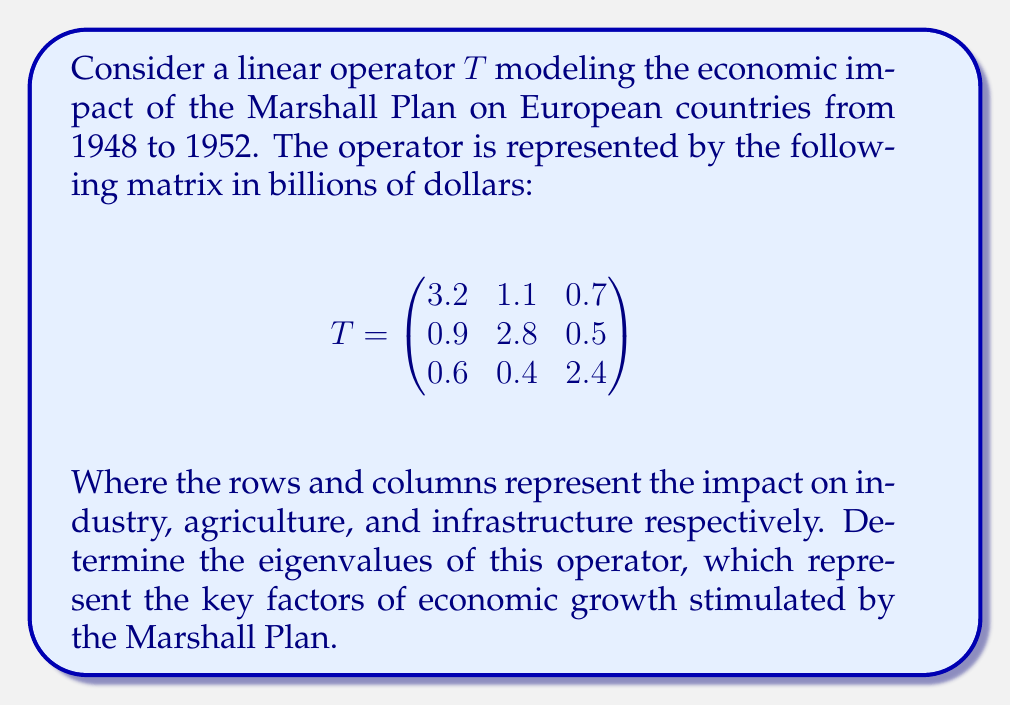Show me your answer to this math problem. To find the eigenvalues of the linear operator T, we need to solve the characteristic equation:

$det(T - \lambda I) = 0$

Where $I$ is the 3x3 identity matrix and $\lambda$ represents the eigenvalues.

Step 1: Set up the characteristic equation:
$$det\begin{pmatrix}
3.2 - \lambda & 1.1 & 0.7 \\
0.9 & 2.8 - \lambda & 0.5 \\
0.6 & 0.4 & 2.4 - \lambda
\end{pmatrix} = 0$$

Step 2: Expand the determinant:
$$(3.2 - \lambda)[(2.8 - \lambda)(2.4 - \lambda) - 0.2] - 1.1[0.9(2.4 - \lambda) - 0.3] + 0.7[0.9(0.4) - 0.6(2.8 - \lambda)] = 0$$

Step 3: Simplify and collect terms:
$$\lambda^3 - 8.4\lambda^2 + 22.12\lambda - 18.256 = 0$$

Step 4: Solve the cubic equation. This can be done using the cubic formula or numerical methods. The roots of this equation are the eigenvalues.

Using a numerical solver, we find the eigenvalues to be approximately:

$\lambda_1 \approx 3.8732$
$\lambda_2 \approx 2.6134$
$\lambda_3 \approx 1.9134$

These eigenvalues represent the principal directions of economic growth stimulated by the Marshall Plan, with the largest eigenvalue indicating the most significant factor.
Answer: $\lambda_1 \approx 3.8732$, $\lambda_2 \approx 2.6134$, $\lambda_3 \approx 1.9134$ 